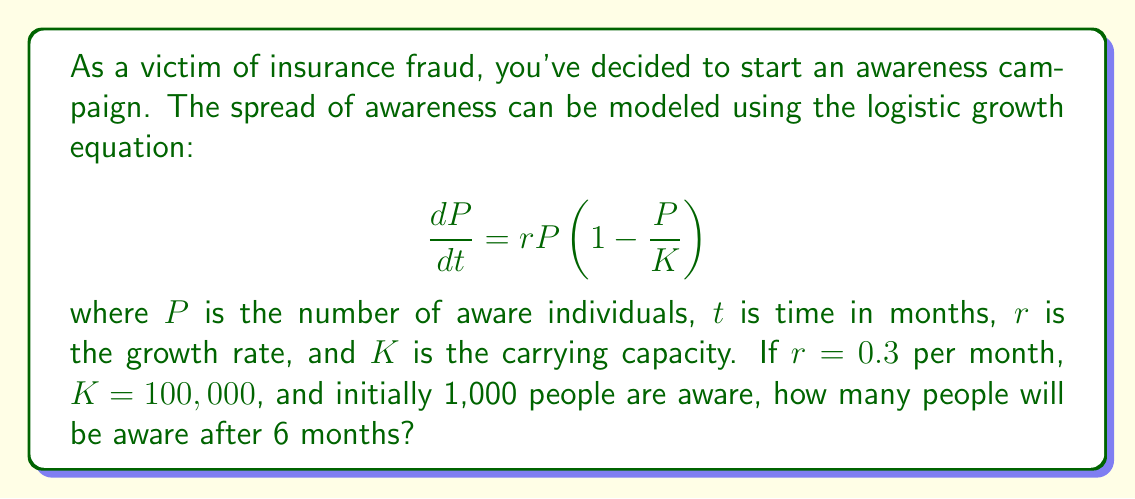What is the answer to this math problem? To solve this problem, we'll use the logistic growth equation and its solution:

1) The logistic growth equation is:
   $$\frac{dP}{dt} = rP(1-\frac{P}{K})$$

2) The solution to this equation is:
   $$P(t) = \frac{K}{1 + (\frac{K}{P_0} - 1)e^{-rt}}$$

   Where $P_0$ is the initial population.

3) We're given:
   $r = 0.3$ per month
   $K = 100,000$
   $P_0 = 1,000$
   $t = 6$ months

4) Let's substitute these values into the solution:

   $$P(6) = \frac{100,000}{1 + (\frac{100,000}{1,000} - 1)e^{-0.3(6)}}$$

5) Simplify:
   $$P(6) = \frac{100,000}{1 + 99e^{-1.8}}$$

6) Calculate:
   $$P(6) = \frac{100,000}{1 + 99(0.1653)} = \frac{100,000}{17.3647}$$

7) Solve:
   $$P(6) \approx 5,759$$

Therefore, after 6 months, approximately 5,759 people will be aware of insurance fraud.
Answer: 5,759 people 